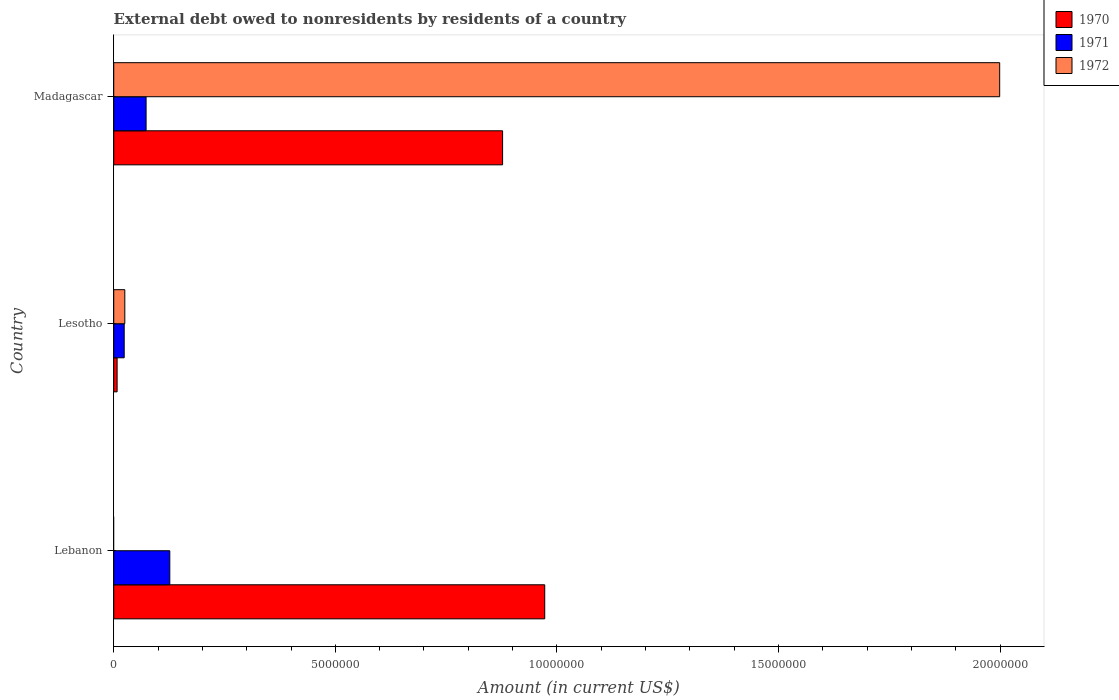Are the number of bars per tick equal to the number of legend labels?
Your answer should be compact. No. Are the number of bars on each tick of the Y-axis equal?
Your answer should be very brief. No. How many bars are there on the 1st tick from the top?
Your answer should be compact. 3. How many bars are there on the 1st tick from the bottom?
Make the answer very short. 2. What is the label of the 3rd group of bars from the top?
Give a very brief answer. Lebanon. What is the external debt owed by residents in 1971 in Lebanon?
Keep it short and to the point. 1.26e+06. Across all countries, what is the maximum external debt owed by residents in 1970?
Your response must be concise. 9.73e+06. Across all countries, what is the minimum external debt owed by residents in 1970?
Keep it short and to the point. 7.60e+04. In which country was the external debt owed by residents in 1970 maximum?
Ensure brevity in your answer.  Lebanon. What is the total external debt owed by residents in 1970 in the graph?
Offer a terse response. 1.86e+07. What is the difference between the external debt owed by residents in 1971 in Lesotho and that in Madagascar?
Your answer should be compact. -4.94e+05. What is the difference between the external debt owed by residents in 1970 in Lesotho and the external debt owed by residents in 1971 in Lebanon?
Offer a terse response. -1.19e+06. What is the average external debt owed by residents in 1971 per country?
Provide a short and direct response. 7.44e+05. What is the difference between the external debt owed by residents in 1970 and external debt owed by residents in 1972 in Madagascar?
Your answer should be compact. -1.12e+07. What is the ratio of the external debt owed by residents in 1971 in Lebanon to that in Lesotho?
Your answer should be very brief. 5.36. Is the difference between the external debt owed by residents in 1970 in Lesotho and Madagascar greater than the difference between the external debt owed by residents in 1972 in Lesotho and Madagascar?
Make the answer very short. Yes. What is the difference between the highest and the second highest external debt owed by residents in 1971?
Provide a short and direct response. 5.35e+05. What is the difference between the highest and the lowest external debt owed by residents in 1971?
Offer a terse response. 1.03e+06. Is it the case that in every country, the sum of the external debt owed by residents in 1971 and external debt owed by residents in 1972 is greater than the external debt owed by residents in 1970?
Provide a succinct answer. No. Are all the bars in the graph horizontal?
Your answer should be very brief. Yes. How many countries are there in the graph?
Offer a very short reply. 3. Does the graph contain any zero values?
Give a very brief answer. Yes. How many legend labels are there?
Your answer should be very brief. 3. What is the title of the graph?
Your answer should be very brief. External debt owed to nonresidents by residents of a country. Does "1967" appear as one of the legend labels in the graph?
Give a very brief answer. No. What is the label or title of the X-axis?
Make the answer very short. Amount (in current US$). What is the label or title of the Y-axis?
Ensure brevity in your answer.  Country. What is the Amount (in current US$) in 1970 in Lebanon?
Make the answer very short. 9.73e+06. What is the Amount (in current US$) in 1971 in Lebanon?
Offer a very short reply. 1.26e+06. What is the Amount (in current US$) of 1970 in Lesotho?
Ensure brevity in your answer.  7.60e+04. What is the Amount (in current US$) of 1971 in Lesotho?
Your answer should be compact. 2.36e+05. What is the Amount (in current US$) of 1972 in Lesotho?
Give a very brief answer. 2.50e+05. What is the Amount (in current US$) in 1970 in Madagascar?
Offer a very short reply. 8.78e+06. What is the Amount (in current US$) of 1971 in Madagascar?
Offer a very short reply. 7.30e+05. What is the Amount (in current US$) of 1972 in Madagascar?
Your answer should be compact. 2.00e+07. Across all countries, what is the maximum Amount (in current US$) in 1970?
Keep it short and to the point. 9.73e+06. Across all countries, what is the maximum Amount (in current US$) in 1971?
Keep it short and to the point. 1.26e+06. Across all countries, what is the maximum Amount (in current US$) in 1972?
Your answer should be compact. 2.00e+07. Across all countries, what is the minimum Amount (in current US$) of 1970?
Make the answer very short. 7.60e+04. Across all countries, what is the minimum Amount (in current US$) of 1971?
Offer a terse response. 2.36e+05. What is the total Amount (in current US$) in 1970 in the graph?
Provide a succinct answer. 1.86e+07. What is the total Amount (in current US$) of 1971 in the graph?
Your response must be concise. 2.23e+06. What is the total Amount (in current US$) in 1972 in the graph?
Make the answer very short. 2.02e+07. What is the difference between the Amount (in current US$) in 1970 in Lebanon and that in Lesotho?
Make the answer very short. 9.65e+06. What is the difference between the Amount (in current US$) in 1971 in Lebanon and that in Lesotho?
Provide a succinct answer. 1.03e+06. What is the difference between the Amount (in current US$) of 1970 in Lebanon and that in Madagascar?
Your response must be concise. 9.51e+05. What is the difference between the Amount (in current US$) of 1971 in Lebanon and that in Madagascar?
Your response must be concise. 5.35e+05. What is the difference between the Amount (in current US$) of 1970 in Lesotho and that in Madagascar?
Make the answer very short. -8.70e+06. What is the difference between the Amount (in current US$) in 1971 in Lesotho and that in Madagascar?
Your response must be concise. -4.94e+05. What is the difference between the Amount (in current US$) of 1972 in Lesotho and that in Madagascar?
Offer a very short reply. -1.97e+07. What is the difference between the Amount (in current US$) of 1970 in Lebanon and the Amount (in current US$) of 1971 in Lesotho?
Give a very brief answer. 9.49e+06. What is the difference between the Amount (in current US$) in 1970 in Lebanon and the Amount (in current US$) in 1972 in Lesotho?
Offer a very short reply. 9.48e+06. What is the difference between the Amount (in current US$) of 1971 in Lebanon and the Amount (in current US$) of 1972 in Lesotho?
Offer a very short reply. 1.02e+06. What is the difference between the Amount (in current US$) of 1970 in Lebanon and the Amount (in current US$) of 1971 in Madagascar?
Offer a very short reply. 9.00e+06. What is the difference between the Amount (in current US$) of 1970 in Lebanon and the Amount (in current US$) of 1972 in Madagascar?
Your answer should be compact. -1.03e+07. What is the difference between the Amount (in current US$) of 1971 in Lebanon and the Amount (in current US$) of 1972 in Madagascar?
Provide a short and direct response. -1.87e+07. What is the difference between the Amount (in current US$) in 1970 in Lesotho and the Amount (in current US$) in 1971 in Madagascar?
Provide a succinct answer. -6.54e+05. What is the difference between the Amount (in current US$) of 1970 in Lesotho and the Amount (in current US$) of 1972 in Madagascar?
Your answer should be compact. -1.99e+07. What is the difference between the Amount (in current US$) in 1971 in Lesotho and the Amount (in current US$) in 1972 in Madagascar?
Your answer should be very brief. -1.98e+07. What is the average Amount (in current US$) of 1970 per country?
Your answer should be very brief. 6.19e+06. What is the average Amount (in current US$) in 1971 per country?
Keep it short and to the point. 7.44e+05. What is the average Amount (in current US$) in 1972 per country?
Offer a very short reply. 6.75e+06. What is the difference between the Amount (in current US$) in 1970 and Amount (in current US$) in 1971 in Lebanon?
Offer a terse response. 8.46e+06. What is the difference between the Amount (in current US$) of 1970 and Amount (in current US$) of 1971 in Lesotho?
Ensure brevity in your answer.  -1.60e+05. What is the difference between the Amount (in current US$) of 1970 and Amount (in current US$) of 1972 in Lesotho?
Your answer should be very brief. -1.74e+05. What is the difference between the Amount (in current US$) in 1971 and Amount (in current US$) in 1972 in Lesotho?
Keep it short and to the point. -1.40e+04. What is the difference between the Amount (in current US$) of 1970 and Amount (in current US$) of 1971 in Madagascar?
Your answer should be very brief. 8.04e+06. What is the difference between the Amount (in current US$) of 1970 and Amount (in current US$) of 1972 in Madagascar?
Your answer should be very brief. -1.12e+07. What is the difference between the Amount (in current US$) of 1971 and Amount (in current US$) of 1972 in Madagascar?
Give a very brief answer. -1.93e+07. What is the ratio of the Amount (in current US$) of 1970 in Lebanon to that in Lesotho?
Keep it short and to the point. 127.97. What is the ratio of the Amount (in current US$) in 1971 in Lebanon to that in Lesotho?
Offer a very short reply. 5.36. What is the ratio of the Amount (in current US$) in 1970 in Lebanon to that in Madagascar?
Your answer should be very brief. 1.11. What is the ratio of the Amount (in current US$) in 1971 in Lebanon to that in Madagascar?
Offer a terse response. 1.73. What is the ratio of the Amount (in current US$) in 1970 in Lesotho to that in Madagascar?
Provide a succinct answer. 0.01. What is the ratio of the Amount (in current US$) in 1971 in Lesotho to that in Madagascar?
Provide a short and direct response. 0.32. What is the ratio of the Amount (in current US$) of 1972 in Lesotho to that in Madagascar?
Your answer should be compact. 0.01. What is the difference between the highest and the second highest Amount (in current US$) of 1970?
Keep it short and to the point. 9.51e+05. What is the difference between the highest and the second highest Amount (in current US$) in 1971?
Your answer should be compact. 5.35e+05. What is the difference between the highest and the lowest Amount (in current US$) of 1970?
Your answer should be very brief. 9.65e+06. What is the difference between the highest and the lowest Amount (in current US$) of 1971?
Ensure brevity in your answer.  1.03e+06. What is the difference between the highest and the lowest Amount (in current US$) of 1972?
Offer a terse response. 2.00e+07. 